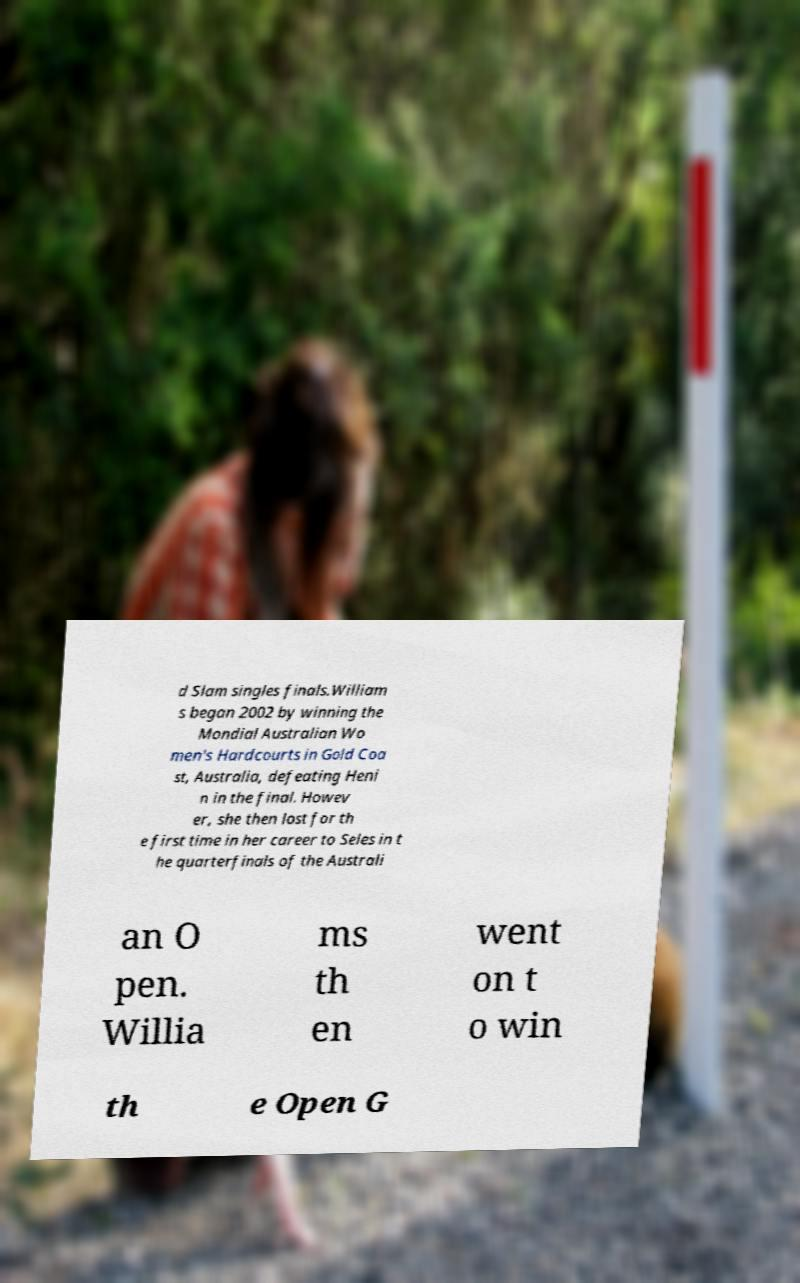There's text embedded in this image that I need extracted. Can you transcribe it verbatim? d Slam singles finals.William s began 2002 by winning the Mondial Australian Wo men's Hardcourts in Gold Coa st, Australia, defeating Heni n in the final. Howev er, she then lost for th e first time in her career to Seles in t he quarterfinals of the Australi an O pen. Willia ms th en went on t o win th e Open G 